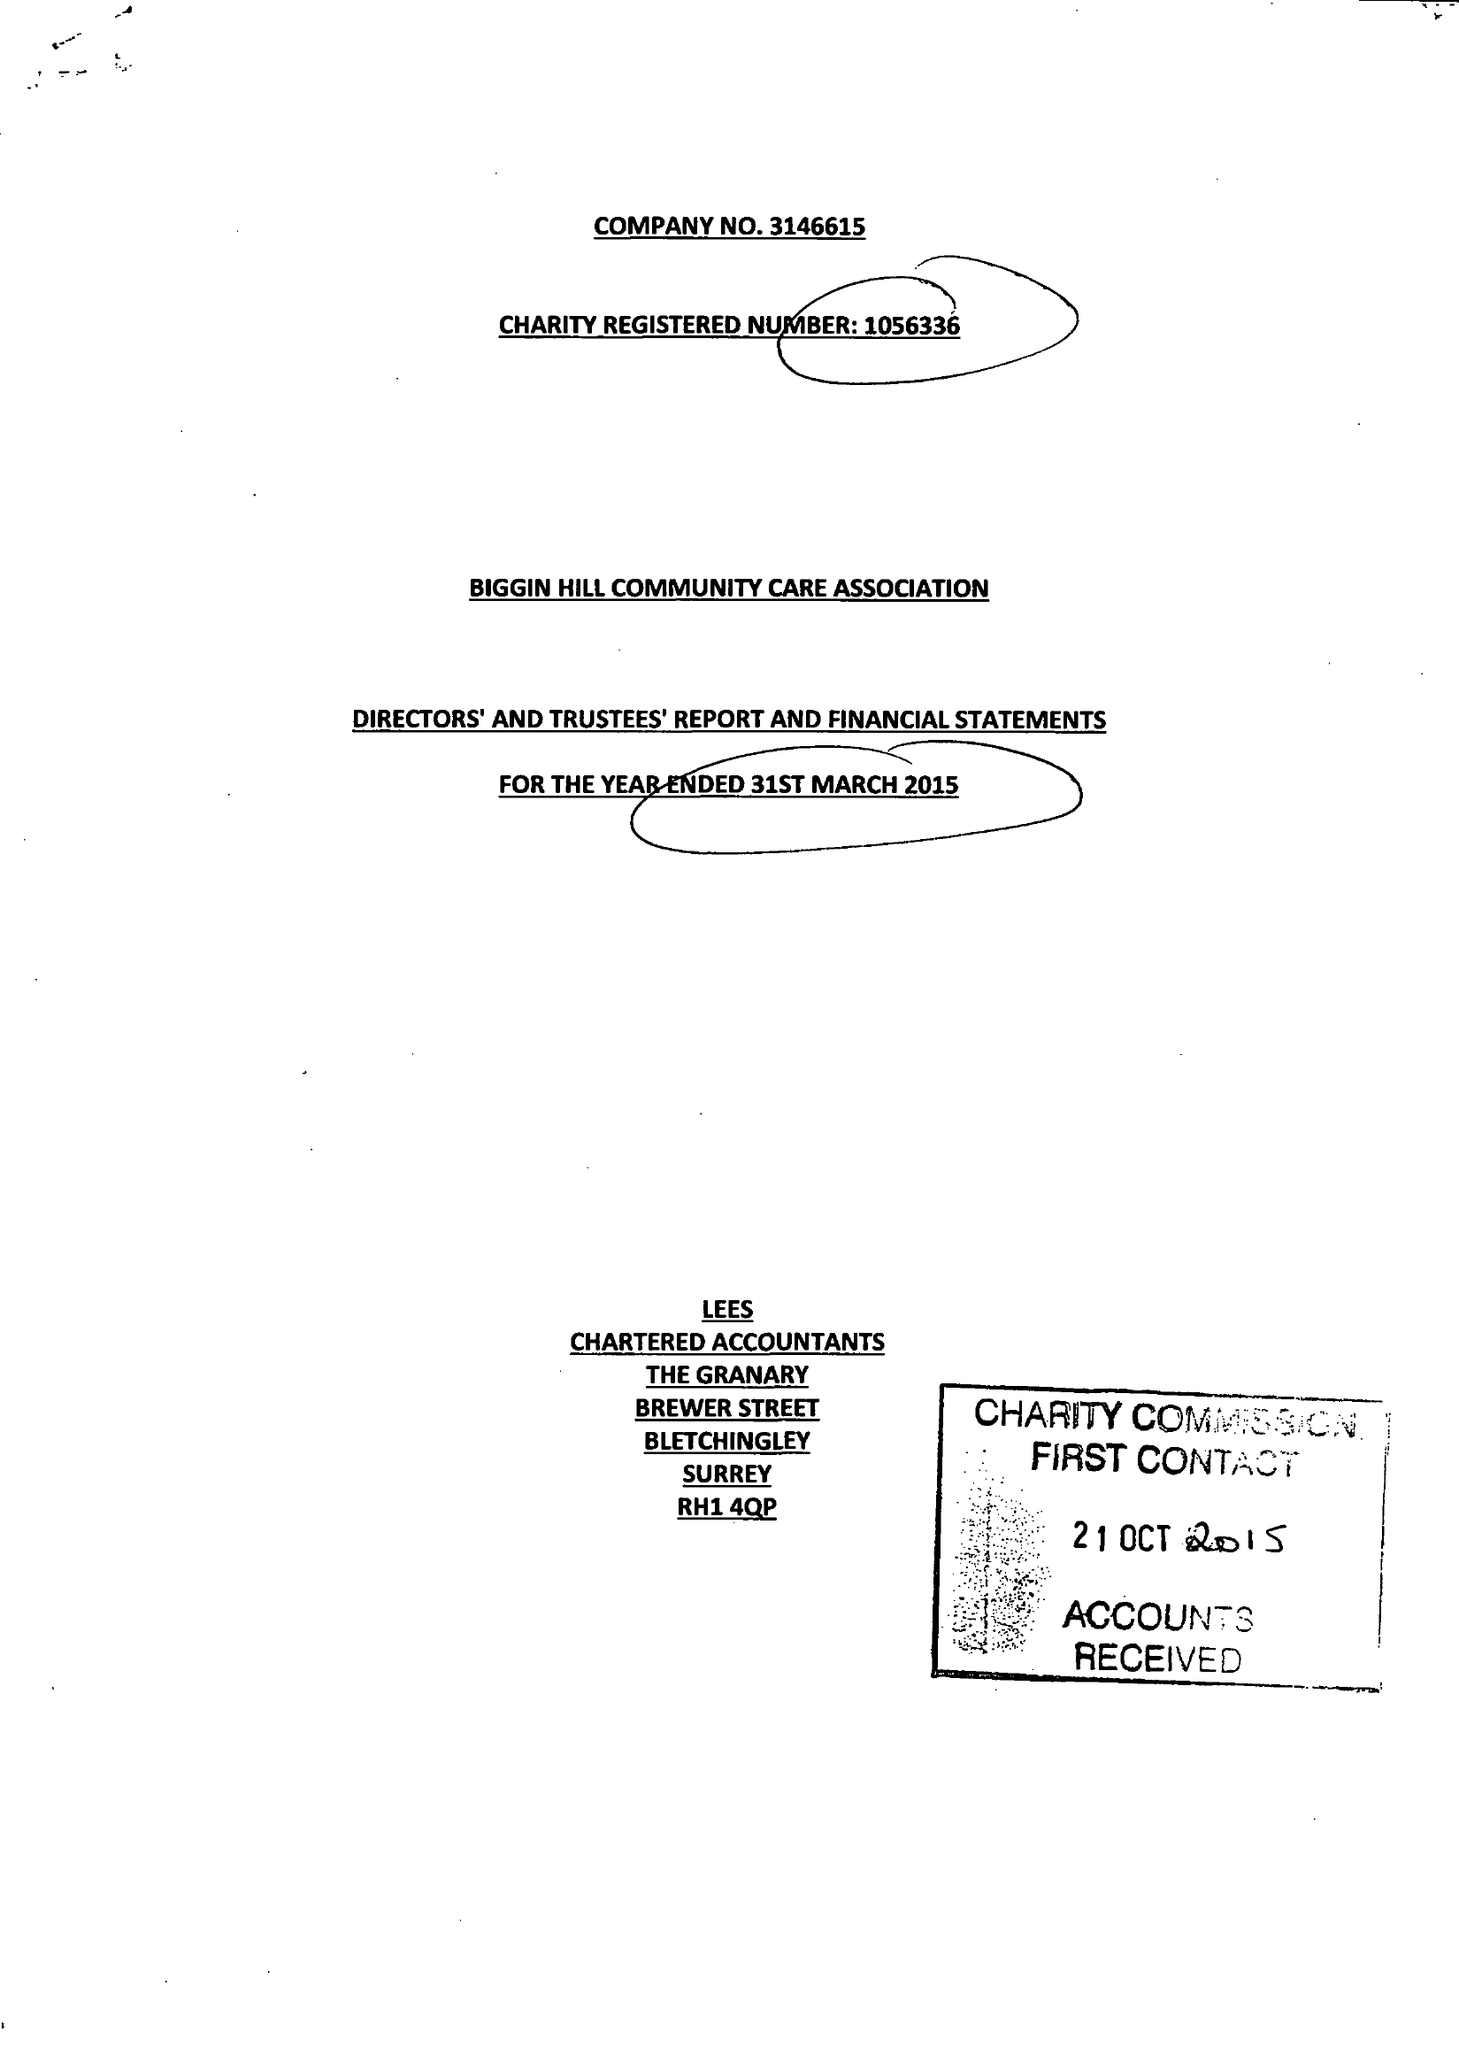What is the value for the charity_name?
Answer the question using a single word or phrase. Biggin Hill Community Care Association 